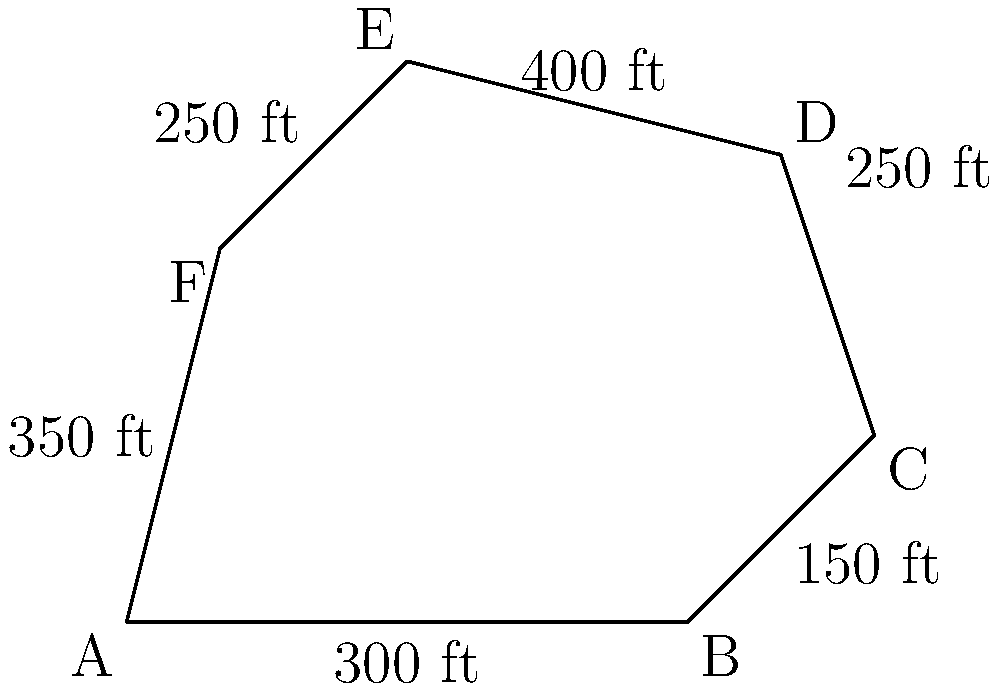As a Chicago news reporter covering local developments, you're tasked with reporting on a proposed expansion of Grant Park. The park's current shape is represented by the irregular hexagon ABCDEF in the diagram. If each unit in the diagram represents 100 feet, what is the total area of Grant Park in square feet? To find the area of this irregular hexagon, we can divide it into triangles and use the formula for the area of a triangle: $A = \frac{1}{2} \times base \times height$.

1) First, let's divide the hexagon into four triangles: ABC, ACD, ADE, and AEF.

2) For triangle ABC:
   Base = 600 ft, Height ≈ 200 ft
   Area_ABC = $\frac{1}{2} \times 600 \times 200 = 60,000$ sq ft

3) For triangle ACD:
   We can estimate the base (AC) to be about 800 ft, and the height to be about 300 ft
   Area_ACD = $\frac{1}{2} \times 800 \times 300 = 120,000$ sq ft

4) For triangle ADE:
   Base ≈ 700 ft, Height ≈ 400 ft
   Area_ADE = $\frac{1}{2} \times 700 \times 400 = 140,000$ sq ft

5) For triangle AEF:
   Base = 300 ft, Height ≈ 400 ft
   Area_AEF = $\frac{1}{2} \times 300 \times 400 = 60,000$ sq ft

6) Total area = Area_ABC + Area_ACD + Area_ADE + Area_AEF
               = 60,000 + 120,000 + 140,000 + 60,000
               = 380,000 sq ft

Therefore, the total area of Grant Park is approximately 380,000 square feet.
Answer: 380,000 square feet 